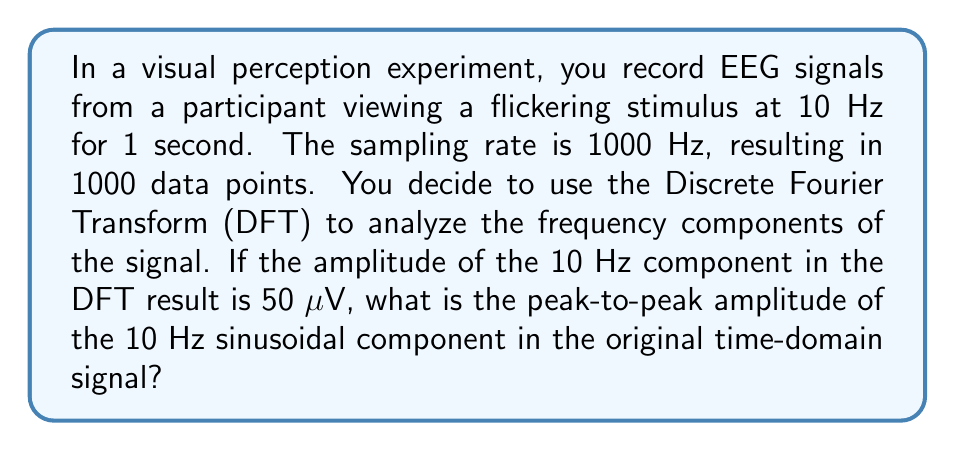Help me with this question. To solve this problem, we need to understand the relationship between the DFT amplitude and the time-domain signal amplitude. Let's break it down step-by-step:

1. The Discrete Fourier Transform (DFT) decomposes a signal into its frequency components. For a real-valued signal, the DFT result is symmetric, and we typically work with the first half of the spectrum.

2. The DFT amplitude represents the magnitude of each frequency component. For a sinusoidal signal, this amplitude is related to the peak amplitude of the time-domain signal.

3. For a pure sinusoid, the relationship between the DFT amplitude and the peak amplitude of the time-domain signal is:

   $$ A_{DFT} = \frac{N}{2} A_{peak} $$

   Where $A_{DFT}$ is the DFT amplitude, $N$ is the number of samples, and $A_{peak}$ is the peak amplitude of the time-domain signal.

4. In this case, we have:
   - $A_{DFT} = 50 \text{ μV}$
   - $N = 1000$ samples

5. Rearranging the formula to solve for $A_{peak}$:

   $$ A_{peak} = \frac{2A_{DFT}}{N} = \frac{2 \cdot 50}{1000} = 0.1 \text{ μV} $$

6. This gives us the peak amplitude, but the question asks for the peak-to-peak amplitude. The peak-to-peak amplitude is twice the peak amplitude:

   $$ A_{peak-to-peak} = 2A_{peak} = 2 \cdot 0.1 = 0.2 \text{ μV} $$

Therefore, the peak-to-peak amplitude of the 10 Hz sinusoidal component in the original time-domain signal is 0.2 μV.
Answer: 0.2 μV 